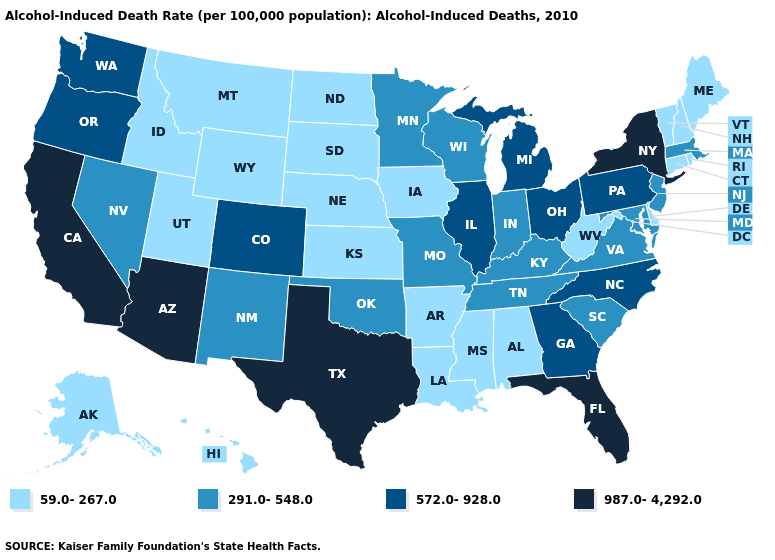Does Hawaii have the highest value in the USA?
Keep it brief. No. Among the states that border Massachusetts , which have the lowest value?
Answer briefly. Connecticut, New Hampshire, Rhode Island, Vermont. Does the map have missing data?
Concise answer only. No. Does the map have missing data?
Answer briefly. No. Among the states that border Connecticut , which have the highest value?
Quick response, please. New York. Does North Carolina have a lower value than Arkansas?
Be succinct. No. Is the legend a continuous bar?
Concise answer only. No. Which states have the lowest value in the South?
Short answer required. Alabama, Arkansas, Delaware, Louisiana, Mississippi, West Virginia. Which states have the highest value in the USA?
Answer briefly. Arizona, California, Florida, New York, Texas. Among the states that border Texas , does Louisiana have the lowest value?
Short answer required. Yes. What is the highest value in the South ?
Keep it brief. 987.0-4,292.0. What is the value of South Dakota?
Short answer required. 59.0-267.0. Among the states that border Maryland , which have the lowest value?
Short answer required. Delaware, West Virginia. Which states have the lowest value in the USA?
Keep it brief. Alabama, Alaska, Arkansas, Connecticut, Delaware, Hawaii, Idaho, Iowa, Kansas, Louisiana, Maine, Mississippi, Montana, Nebraska, New Hampshire, North Dakota, Rhode Island, South Dakota, Utah, Vermont, West Virginia, Wyoming. What is the highest value in the USA?
Write a very short answer. 987.0-4,292.0. 